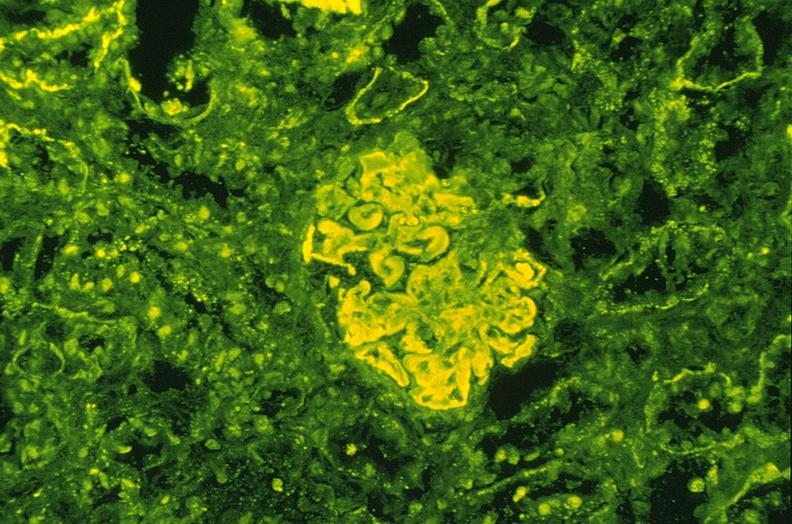s bone nearly completely filled with tumor primary present?
Answer the question using a single word or phrase. No 